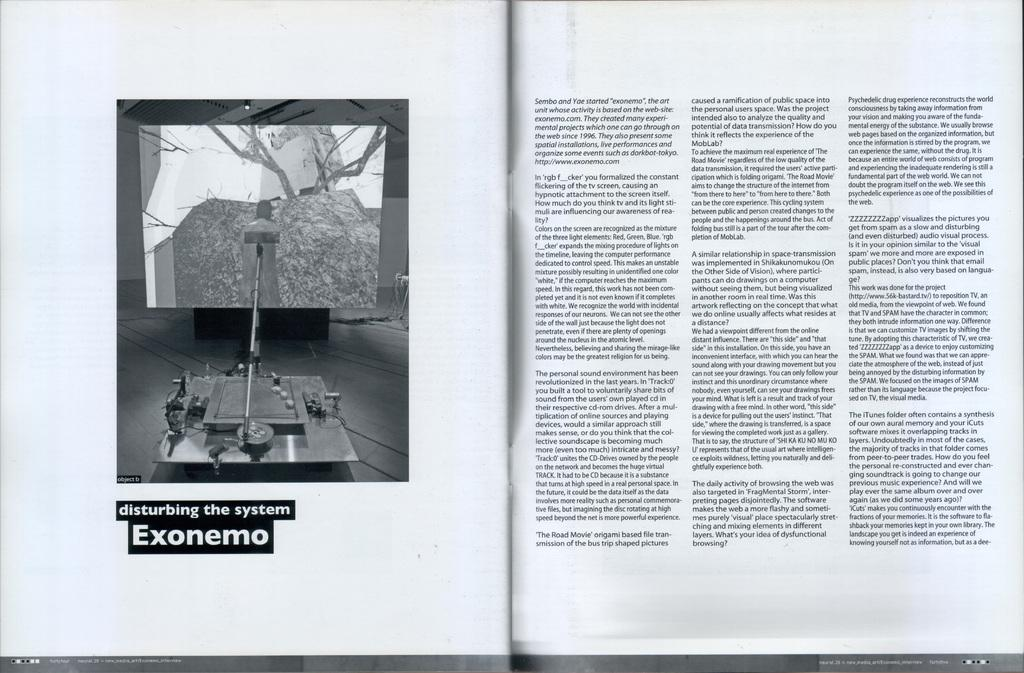<image>
Present a compact description of the photo's key features. a book that is opened with a reference to EXONEMO. 